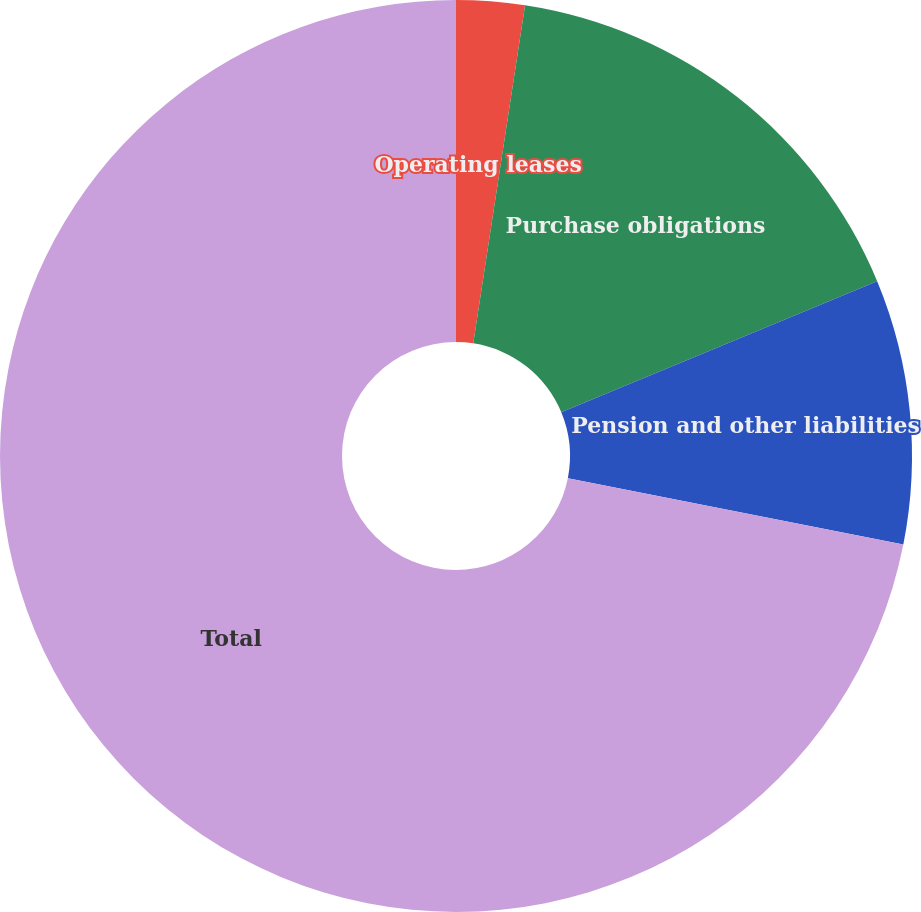Convert chart to OTSL. <chart><loc_0><loc_0><loc_500><loc_500><pie_chart><fcel>Operating leases<fcel>Purchase obligations<fcel>Pension and other liabilities<fcel>Total<nl><fcel>2.42%<fcel>16.32%<fcel>9.37%<fcel>71.89%<nl></chart> 